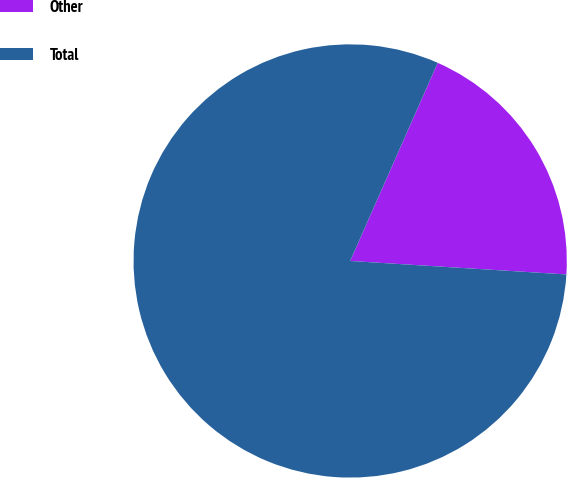Convert chart to OTSL. <chart><loc_0><loc_0><loc_500><loc_500><pie_chart><fcel>Other<fcel>Total<nl><fcel>19.37%<fcel>80.63%<nl></chart> 